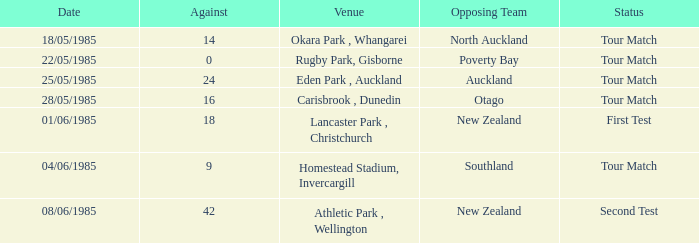Which venue had an against score smaller than 18 when the opposing team was North Auckland? Okara Park , Whangarei. 